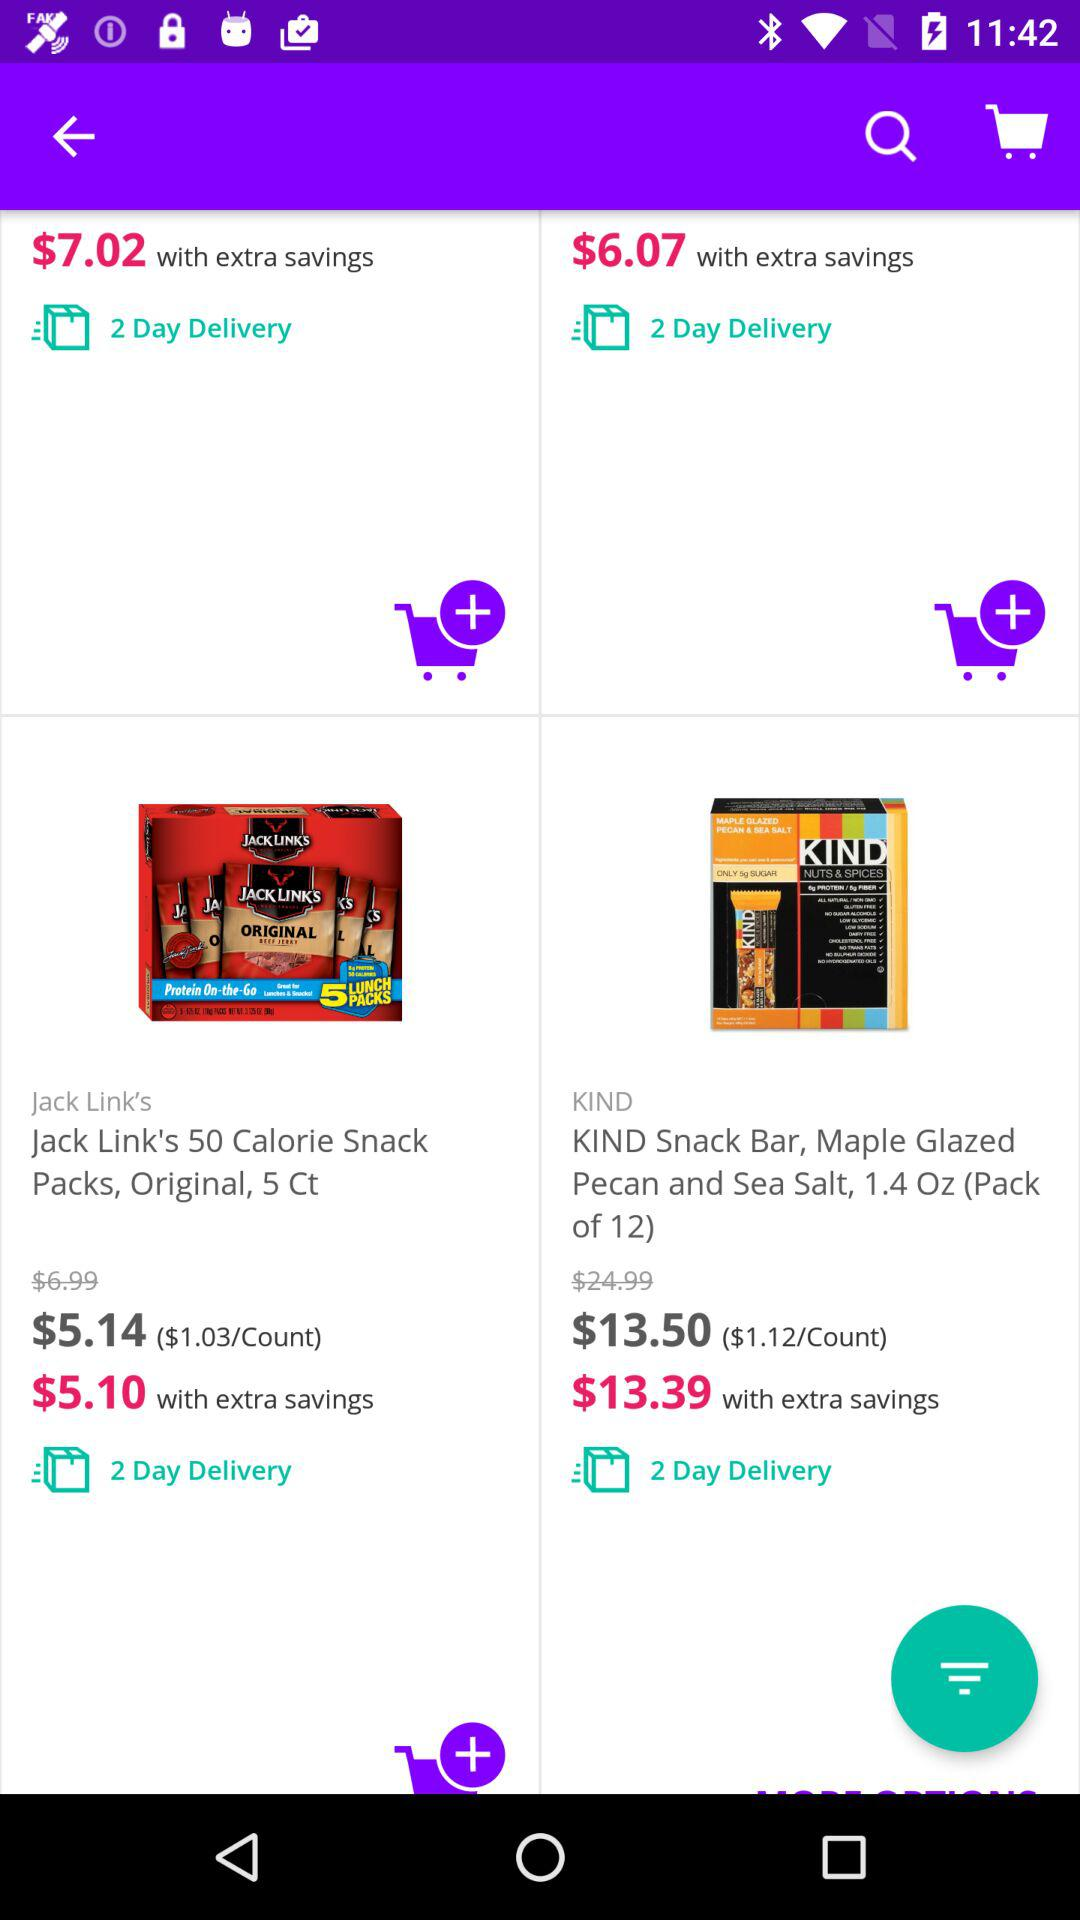What is the price of "KIND Snack Bar" pack with extra savings? The price is $13.39. 